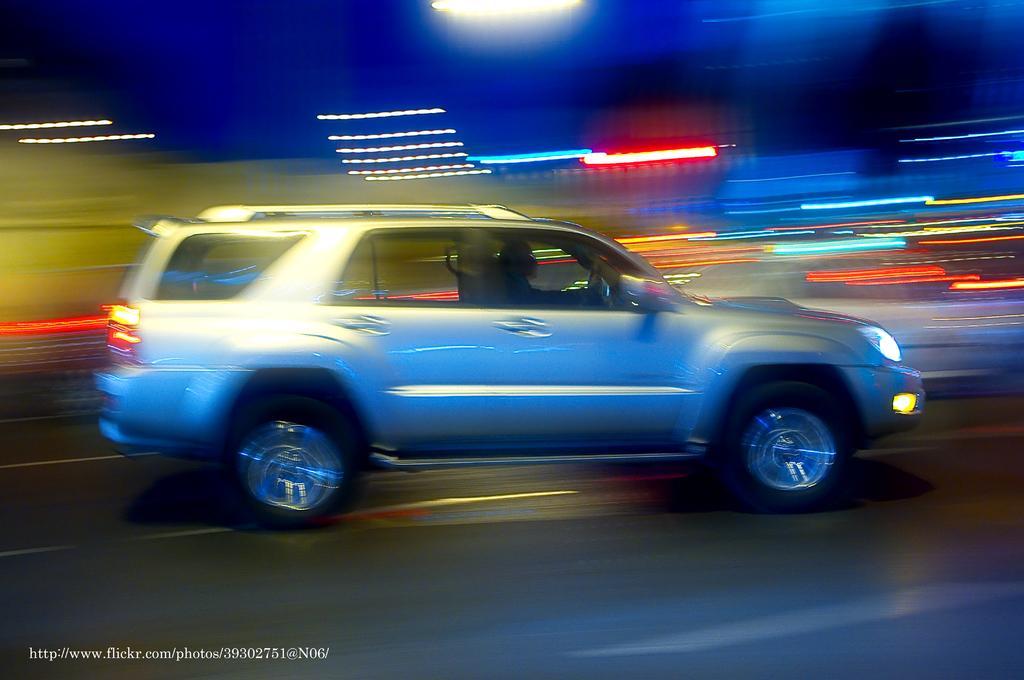Can you describe this image briefly? This image is taken outdoors. At the bottom of the image there is a road. In the middle of the image a car is moving on the road. In this image the background is a little blurred and there are a few lights. 